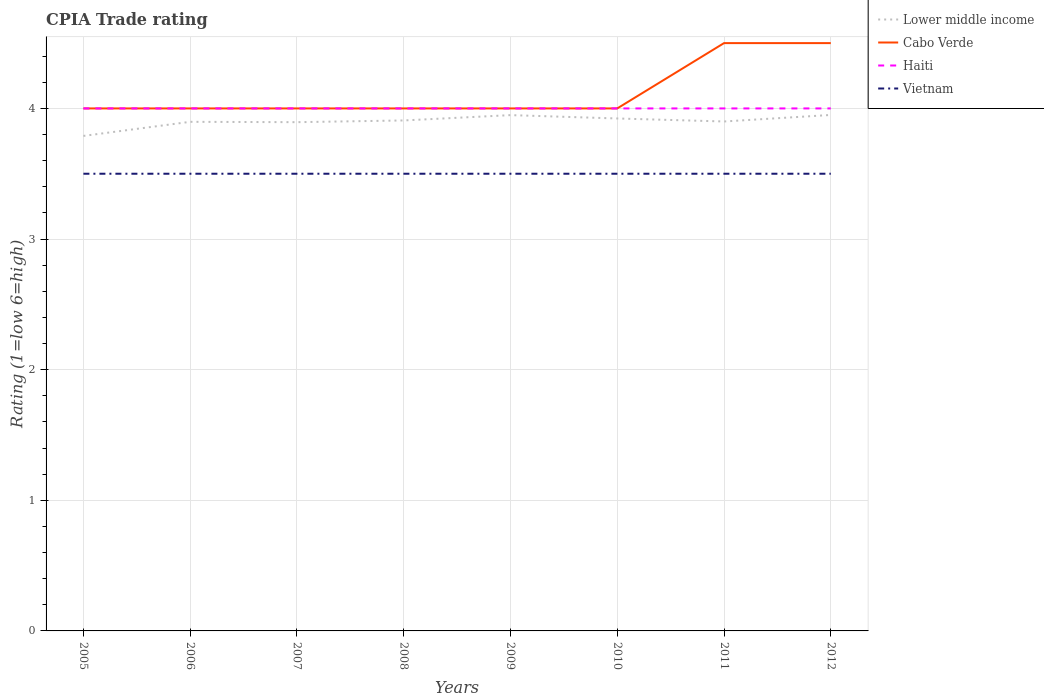Does the line corresponding to Lower middle income intersect with the line corresponding to Cabo Verde?
Your answer should be very brief. No. Is the number of lines equal to the number of legend labels?
Provide a short and direct response. Yes. In which year was the CPIA rating in Vietnam maximum?
Give a very brief answer. 2005. What is the total CPIA rating in Lower middle income in the graph?
Your answer should be compact. -0.12. What is the difference between the highest and the second highest CPIA rating in Lower middle income?
Offer a very short reply. 0.16. What is the difference between the highest and the lowest CPIA rating in Vietnam?
Ensure brevity in your answer.  0. How many lines are there?
Keep it short and to the point. 4. What is the difference between two consecutive major ticks on the Y-axis?
Your response must be concise. 1. Are the values on the major ticks of Y-axis written in scientific E-notation?
Offer a terse response. No. Does the graph contain any zero values?
Your answer should be very brief. No. How are the legend labels stacked?
Provide a succinct answer. Vertical. What is the title of the graph?
Offer a terse response. CPIA Trade rating. Does "European Union" appear as one of the legend labels in the graph?
Provide a succinct answer. No. What is the Rating (1=low 6=high) in Lower middle income in 2005?
Ensure brevity in your answer.  3.79. What is the Rating (1=low 6=high) in Cabo Verde in 2005?
Offer a very short reply. 4. What is the Rating (1=low 6=high) in Lower middle income in 2006?
Make the answer very short. 3.9. What is the Rating (1=low 6=high) in Cabo Verde in 2006?
Give a very brief answer. 4. What is the Rating (1=low 6=high) in Haiti in 2006?
Provide a short and direct response. 4. What is the Rating (1=low 6=high) of Lower middle income in 2007?
Your response must be concise. 3.89. What is the Rating (1=low 6=high) in Cabo Verde in 2007?
Offer a very short reply. 4. What is the Rating (1=low 6=high) of Lower middle income in 2008?
Ensure brevity in your answer.  3.91. What is the Rating (1=low 6=high) of Vietnam in 2008?
Give a very brief answer. 3.5. What is the Rating (1=low 6=high) in Lower middle income in 2009?
Your response must be concise. 3.95. What is the Rating (1=low 6=high) of Haiti in 2009?
Offer a terse response. 4. What is the Rating (1=low 6=high) in Lower middle income in 2010?
Your response must be concise. 3.92. What is the Rating (1=low 6=high) in Haiti in 2010?
Provide a succinct answer. 4. What is the Rating (1=low 6=high) of Vietnam in 2010?
Your answer should be compact. 3.5. What is the Rating (1=low 6=high) of Haiti in 2011?
Make the answer very short. 4. What is the Rating (1=low 6=high) of Vietnam in 2011?
Ensure brevity in your answer.  3.5. What is the Rating (1=low 6=high) in Lower middle income in 2012?
Make the answer very short. 3.95. What is the Rating (1=low 6=high) in Cabo Verde in 2012?
Provide a short and direct response. 4.5. What is the Rating (1=low 6=high) in Haiti in 2012?
Make the answer very short. 4. What is the Rating (1=low 6=high) of Vietnam in 2012?
Your answer should be very brief. 3.5. Across all years, what is the maximum Rating (1=low 6=high) in Lower middle income?
Offer a terse response. 3.95. Across all years, what is the maximum Rating (1=low 6=high) of Cabo Verde?
Your answer should be very brief. 4.5. Across all years, what is the maximum Rating (1=low 6=high) of Haiti?
Your response must be concise. 4. Across all years, what is the minimum Rating (1=low 6=high) in Lower middle income?
Your response must be concise. 3.79. Across all years, what is the minimum Rating (1=low 6=high) in Haiti?
Make the answer very short. 4. Across all years, what is the minimum Rating (1=low 6=high) of Vietnam?
Offer a terse response. 3.5. What is the total Rating (1=low 6=high) of Lower middle income in the graph?
Offer a terse response. 31.21. What is the total Rating (1=low 6=high) of Haiti in the graph?
Offer a very short reply. 32. What is the total Rating (1=low 6=high) in Vietnam in the graph?
Provide a short and direct response. 28. What is the difference between the Rating (1=low 6=high) of Lower middle income in 2005 and that in 2006?
Offer a terse response. -0.11. What is the difference between the Rating (1=low 6=high) in Haiti in 2005 and that in 2006?
Offer a very short reply. 0. What is the difference between the Rating (1=low 6=high) of Lower middle income in 2005 and that in 2007?
Your answer should be compact. -0.11. What is the difference between the Rating (1=low 6=high) of Lower middle income in 2005 and that in 2008?
Give a very brief answer. -0.12. What is the difference between the Rating (1=low 6=high) in Haiti in 2005 and that in 2008?
Your answer should be very brief. 0. What is the difference between the Rating (1=low 6=high) in Vietnam in 2005 and that in 2008?
Provide a short and direct response. 0. What is the difference between the Rating (1=low 6=high) in Lower middle income in 2005 and that in 2009?
Provide a succinct answer. -0.16. What is the difference between the Rating (1=low 6=high) of Vietnam in 2005 and that in 2009?
Your response must be concise. 0. What is the difference between the Rating (1=low 6=high) in Lower middle income in 2005 and that in 2010?
Offer a terse response. -0.13. What is the difference between the Rating (1=low 6=high) of Haiti in 2005 and that in 2010?
Offer a very short reply. 0. What is the difference between the Rating (1=low 6=high) of Lower middle income in 2005 and that in 2011?
Keep it short and to the point. -0.11. What is the difference between the Rating (1=low 6=high) of Cabo Verde in 2005 and that in 2011?
Make the answer very short. -0.5. What is the difference between the Rating (1=low 6=high) of Lower middle income in 2005 and that in 2012?
Give a very brief answer. -0.16. What is the difference between the Rating (1=low 6=high) in Vietnam in 2005 and that in 2012?
Provide a short and direct response. 0. What is the difference between the Rating (1=low 6=high) in Lower middle income in 2006 and that in 2007?
Your response must be concise. 0. What is the difference between the Rating (1=low 6=high) in Cabo Verde in 2006 and that in 2007?
Give a very brief answer. 0. What is the difference between the Rating (1=low 6=high) of Haiti in 2006 and that in 2007?
Give a very brief answer. 0. What is the difference between the Rating (1=low 6=high) in Vietnam in 2006 and that in 2007?
Make the answer very short. 0. What is the difference between the Rating (1=low 6=high) in Lower middle income in 2006 and that in 2008?
Your answer should be very brief. -0.01. What is the difference between the Rating (1=low 6=high) in Haiti in 2006 and that in 2008?
Make the answer very short. 0. What is the difference between the Rating (1=low 6=high) in Vietnam in 2006 and that in 2008?
Ensure brevity in your answer.  0. What is the difference between the Rating (1=low 6=high) of Lower middle income in 2006 and that in 2009?
Your answer should be compact. -0.05. What is the difference between the Rating (1=low 6=high) in Cabo Verde in 2006 and that in 2009?
Make the answer very short. 0. What is the difference between the Rating (1=low 6=high) of Lower middle income in 2006 and that in 2010?
Your answer should be compact. -0.03. What is the difference between the Rating (1=low 6=high) in Vietnam in 2006 and that in 2010?
Give a very brief answer. 0. What is the difference between the Rating (1=low 6=high) of Lower middle income in 2006 and that in 2011?
Your response must be concise. -0. What is the difference between the Rating (1=low 6=high) in Haiti in 2006 and that in 2011?
Make the answer very short. 0. What is the difference between the Rating (1=low 6=high) in Vietnam in 2006 and that in 2011?
Provide a succinct answer. 0. What is the difference between the Rating (1=low 6=high) of Lower middle income in 2006 and that in 2012?
Your response must be concise. -0.05. What is the difference between the Rating (1=low 6=high) of Cabo Verde in 2006 and that in 2012?
Provide a succinct answer. -0.5. What is the difference between the Rating (1=low 6=high) in Haiti in 2006 and that in 2012?
Offer a very short reply. 0. What is the difference between the Rating (1=low 6=high) in Lower middle income in 2007 and that in 2008?
Keep it short and to the point. -0.01. What is the difference between the Rating (1=low 6=high) of Haiti in 2007 and that in 2008?
Offer a terse response. 0. What is the difference between the Rating (1=low 6=high) of Vietnam in 2007 and that in 2008?
Your response must be concise. 0. What is the difference between the Rating (1=low 6=high) of Lower middle income in 2007 and that in 2009?
Ensure brevity in your answer.  -0.05. What is the difference between the Rating (1=low 6=high) in Cabo Verde in 2007 and that in 2009?
Offer a terse response. 0. What is the difference between the Rating (1=low 6=high) in Vietnam in 2007 and that in 2009?
Offer a terse response. 0. What is the difference between the Rating (1=low 6=high) in Lower middle income in 2007 and that in 2010?
Your answer should be compact. -0.03. What is the difference between the Rating (1=low 6=high) in Lower middle income in 2007 and that in 2011?
Provide a succinct answer. -0.01. What is the difference between the Rating (1=low 6=high) in Haiti in 2007 and that in 2011?
Ensure brevity in your answer.  0. What is the difference between the Rating (1=low 6=high) of Vietnam in 2007 and that in 2011?
Your answer should be very brief. 0. What is the difference between the Rating (1=low 6=high) in Lower middle income in 2007 and that in 2012?
Ensure brevity in your answer.  -0.06. What is the difference between the Rating (1=low 6=high) of Lower middle income in 2008 and that in 2009?
Your answer should be compact. -0.04. What is the difference between the Rating (1=low 6=high) of Cabo Verde in 2008 and that in 2009?
Provide a succinct answer. 0. What is the difference between the Rating (1=low 6=high) of Haiti in 2008 and that in 2009?
Ensure brevity in your answer.  0. What is the difference between the Rating (1=low 6=high) in Lower middle income in 2008 and that in 2010?
Offer a very short reply. -0.02. What is the difference between the Rating (1=low 6=high) in Cabo Verde in 2008 and that in 2010?
Ensure brevity in your answer.  0. What is the difference between the Rating (1=low 6=high) of Lower middle income in 2008 and that in 2011?
Provide a short and direct response. 0.01. What is the difference between the Rating (1=low 6=high) in Cabo Verde in 2008 and that in 2011?
Keep it short and to the point. -0.5. What is the difference between the Rating (1=low 6=high) in Haiti in 2008 and that in 2011?
Ensure brevity in your answer.  0. What is the difference between the Rating (1=low 6=high) in Vietnam in 2008 and that in 2011?
Your answer should be very brief. 0. What is the difference between the Rating (1=low 6=high) of Lower middle income in 2008 and that in 2012?
Your answer should be compact. -0.04. What is the difference between the Rating (1=low 6=high) in Cabo Verde in 2008 and that in 2012?
Your response must be concise. -0.5. What is the difference between the Rating (1=low 6=high) in Lower middle income in 2009 and that in 2010?
Provide a short and direct response. 0.03. What is the difference between the Rating (1=low 6=high) in Vietnam in 2009 and that in 2010?
Keep it short and to the point. 0. What is the difference between the Rating (1=low 6=high) of Lower middle income in 2009 and that in 2011?
Your answer should be compact. 0.05. What is the difference between the Rating (1=low 6=high) in Cabo Verde in 2009 and that in 2011?
Provide a short and direct response. -0.5. What is the difference between the Rating (1=low 6=high) in Vietnam in 2009 and that in 2011?
Provide a short and direct response. 0. What is the difference between the Rating (1=low 6=high) of Lower middle income in 2009 and that in 2012?
Your answer should be compact. -0. What is the difference between the Rating (1=low 6=high) in Cabo Verde in 2009 and that in 2012?
Keep it short and to the point. -0.5. What is the difference between the Rating (1=low 6=high) in Lower middle income in 2010 and that in 2011?
Keep it short and to the point. 0.02. What is the difference between the Rating (1=low 6=high) of Cabo Verde in 2010 and that in 2011?
Make the answer very short. -0.5. What is the difference between the Rating (1=low 6=high) in Haiti in 2010 and that in 2011?
Give a very brief answer. 0. What is the difference between the Rating (1=low 6=high) of Lower middle income in 2010 and that in 2012?
Your answer should be compact. -0.03. What is the difference between the Rating (1=low 6=high) in Cabo Verde in 2010 and that in 2012?
Provide a short and direct response. -0.5. What is the difference between the Rating (1=low 6=high) in Vietnam in 2010 and that in 2012?
Offer a terse response. 0. What is the difference between the Rating (1=low 6=high) in Lower middle income in 2011 and that in 2012?
Provide a succinct answer. -0.05. What is the difference between the Rating (1=low 6=high) in Haiti in 2011 and that in 2012?
Provide a short and direct response. 0. What is the difference between the Rating (1=low 6=high) in Vietnam in 2011 and that in 2012?
Your answer should be compact. 0. What is the difference between the Rating (1=low 6=high) in Lower middle income in 2005 and the Rating (1=low 6=high) in Cabo Verde in 2006?
Provide a short and direct response. -0.21. What is the difference between the Rating (1=low 6=high) in Lower middle income in 2005 and the Rating (1=low 6=high) in Haiti in 2006?
Provide a succinct answer. -0.21. What is the difference between the Rating (1=low 6=high) in Lower middle income in 2005 and the Rating (1=low 6=high) in Vietnam in 2006?
Ensure brevity in your answer.  0.29. What is the difference between the Rating (1=low 6=high) in Cabo Verde in 2005 and the Rating (1=low 6=high) in Vietnam in 2006?
Ensure brevity in your answer.  0.5. What is the difference between the Rating (1=low 6=high) in Haiti in 2005 and the Rating (1=low 6=high) in Vietnam in 2006?
Your answer should be compact. 0.5. What is the difference between the Rating (1=low 6=high) in Lower middle income in 2005 and the Rating (1=low 6=high) in Cabo Verde in 2007?
Provide a succinct answer. -0.21. What is the difference between the Rating (1=low 6=high) in Lower middle income in 2005 and the Rating (1=low 6=high) in Haiti in 2007?
Make the answer very short. -0.21. What is the difference between the Rating (1=low 6=high) of Lower middle income in 2005 and the Rating (1=low 6=high) of Vietnam in 2007?
Ensure brevity in your answer.  0.29. What is the difference between the Rating (1=low 6=high) of Lower middle income in 2005 and the Rating (1=low 6=high) of Cabo Verde in 2008?
Provide a succinct answer. -0.21. What is the difference between the Rating (1=low 6=high) of Lower middle income in 2005 and the Rating (1=low 6=high) of Haiti in 2008?
Make the answer very short. -0.21. What is the difference between the Rating (1=low 6=high) of Lower middle income in 2005 and the Rating (1=low 6=high) of Vietnam in 2008?
Offer a very short reply. 0.29. What is the difference between the Rating (1=low 6=high) of Cabo Verde in 2005 and the Rating (1=low 6=high) of Haiti in 2008?
Your answer should be very brief. 0. What is the difference between the Rating (1=low 6=high) in Cabo Verde in 2005 and the Rating (1=low 6=high) in Vietnam in 2008?
Make the answer very short. 0.5. What is the difference between the Rating (1=low 6=high) of Lower middle income in 2005 and the Rating (1=low 6=high) of Cabo Verde in 2009?
Ensure brevity in your answer.  -0.21. What is the difference between the Rating (1=low 6=high) in Lower middle income in 2005 and the Rating (1=low 6=high) in Haiti in 2009?
Your answer should be compact. -0.21. What is the difference between the Rating (1=low 6=high) of Lower middle income in 2005 and the Rating (1=low 6=high) of Vietnam in 2009?
Ensure brevity in your answer.  0.29. What is the difference between the Rating (1=low 6=high) of Lower middle income in 2005 and the Rating (1=low 6=high) of Cabo Verde in 2010?
Provide a succinct answer. -0.21. What is the difference between the Rating (1=low 6=high) in Lower middle income in 2005 and the Rating (1=low 6=high) in Haiti in 2010?
Provide a short and direct response. -0.21. What is the difference between the Rating (1=low 6=high) of Lower middle income in 2005 and the Rating (1=low 6=high) of Vietnam in 2010?
Your answer should be very brief. 0.29. What is the difference between the Rating (1=low 6=high) in Cabo Verde in 2005 and the Rating (1=low 6=high) in Vietnam in 2010?
Your answer should be very brief. 0.5. What is the difference between the Rating (1=low 6=high) of Haiti in 2005 and the Rating (1=low 6=high) of Vietnam in 2010?
Offer a very short reply. 0.5. What is the difference between the Rating (1=low 6=high) of Lower middle income in 2005 and the Rating (1=low 6=high) of Cabo Verde in 2011?
Offer a terse response. -0.71. What is the difference between the Rating (1=low 6=high) of Lower middle income in 2005 and the Rating (1=low 6=high) of Haiti in 2011?
Offer a terse response. -0.21. What is the difference between the Rating (1=low 6=high) in Lower middle income in 2005 and the Rating (1=low 6=high) in Vietnam in 2011?
Make the answer very short. 0.29. What is the difference between the Rating (1=low 6=high) of Cabo Verde in 2005 and the Rating (1=low 6=high) of Vietnam in 2011?
Your answer should be compact. 0.5. What is the difference between the Rating (1=low 6=high) in Haiti in 2005 and the Rating (1=low 6=high) in Vietnam in 2011?
Provide a succinct answer. 0.5. What is the difference between the Rating (1=low 6=high) in Lower middle income in 2005 and the Rating (1=low 6=high) in Cabo Verde in 2012?
Your answer should be very brief. -0.71. What is the difference between the Rating (1=low 6=high) of Lower middle income in 2005 and the Rating (1=low 6=high) of Haiti in 2012?
Offer a very short reply. -0.21. What is the difference between the Rating (1=low 6=high) of Lower middle income in 2005 and the Rating (1=low 6=high) of Vietnam in 2012?
Provide a succinct answer. 0.29. What is the difference between the Rating (1=low 6=high) of Cabo Verde in 2005 and the Rating (1=low 6=high) of Haiti in 2012?
Your answer should be compact. 0. What is the difference between the Rating (1=low 6=high) in Cabo Verde in 2005 and the Rating (1=low 6=high) in Vietnam in 2012?
Your answer should be compact. 0.5. What is the difference between the Rating (1=low 6=high) of Lower middle income in 2006 and the Rating (1=low 6=high) of Cabo Verde in 2007?
Your answer should be very brief. -0.1. What is the difference between the Rating (1=low 6=high) of Lower middle income in 2006 and the Rating (1=low 6=high) of Haiti in 2007?
Provide a short and direct response. -0.1. What is the difference between the Rating (1=low 6=high) in Lower middle income in 2006 and the Rating (1=low 6=high) in Vietnam in 2007?
Your answer should be compact. 0.4. What is the difference between the Rating (1=low 6=high) in Cabo Verde in 2006 and the Rating (1=low 6=high) in Haiti in 2007?
Offer a very short reply. 0. What is the difference between the Rating (1=low 6=high) in Cabo Verde in 2006 and the Rating (1=low 6=high) in Vietnam in 2007?
Your answer should be very brief. 0.5. What is the difference between the Rating (1=low 6=high) in Haiti in 2006 and the Rating (1=low 6=high) in Vietnam in 2007?
Give a very brief answer. 0.5. What is the difference between the Rating (1=low 6=high) in Lower middle income in 2006 and the Rating (1=low 6=high) in Cabo Verde in 2008?
Offer a very short reply. -0.1. What is the difference between the Rating (1=low 6=high) of Lower middle income in 2006 and the Rating (1=low 6=high) of Haiti in 2008?
Offer a terse response. -0.1. What is the difference between the Rating (1=low 6=high) of Lower middle income in 2006 and the Rating (1=low 6=high) of Vietnam in 2008?
Provide a succinct answer. 0.4. What is the difference between the Rating (1=low 6=high) of Cabo Verde in 2006 and the Rating (1=low 6=high) of Vietnam in 2008?
Provide a short and direct response. 0.5. What is the difference between the Rating (1=low 6=high) in Haiti in 2006 and the Rating (1=low 6=high) in Vietnam in 2008?
Provide a succinct answer. 0.5. What is the difference between the Rating (1=low 6=high) of Lower middle income in 2006 and the Rating (1=low 6=high) of Cabo Verde in 2009?
Give a very brief answer. -0.1. What is the difference between the Rating (1=low 6=high) of Lower middle income in 2006 and the Rating (1=low 6=high) of Haiti in 2009?
Give a very brief answer. -0.1. What is the difference between the Rating (1=low 6=high) of Lower middle income in 2006 and the Rating (1=low 6=high) of Vietnam in 2009?
Ensure brevity in your answer.  0.4. What is the difference between the Rating (1=low 6=high) of Cabo Verde in 2006 and the Rating (1=low 6=high) of Haiti in 2009?
Make the answer very short. 0. What is the difference between the Rating (1=low 6=high) of Cabo Verde in 2006 and the Rating (1=low 6=high) of Vietnam in 2009?
Ensure brevity in your answer.  0.5. What is the difference between the Rating (1=low 6=high) in Haiti in 2006 and the Rating (1=low 6=high) in Vietnam in 2009?
Your answer should be very brief. 0.5. What is the difference between the Rating (1=low 6=high) of Lower middle income in 2006 and the Rating (1=low 6=high) of Cabo Verde in 2010?
Provide a short and direct response. -0.1. What is the difference between the Rating (1=low 6=high) of Lower middle income in 2006 and the Rating (1=low 6=high) of Haiti in 2010?
Provide a succinct answer. -0.1. What is the difference between the Rating (1=low 6=high) in Lower middle income in 2006 and the Rating (1=low 6=high) in Vietnam in 2010?
Provide a succinct answer. 0.4. What is the difference between the Rating (1=low 6=high) of Lower middle income in 2006 and the Rating (1=low 6=high) of Cabo Verde in 2011?
Offer a terse response. -0.6. What is the difference between the Rating (1=low 6=high) of Lower middle income in 2006 and the Rating (1=low 6=high) of Haiti in 2011?
Keep it short and to the point. -0.1. What is the difference between the Rating (1=low 6=high) in Lower middle income in 2006 and the Rating (1=low 6=high) in Vietnam in 2011?
Provide a succinct answer. 0.4. What is the difference between the Rating (1=low 6=high) in Cabo Verde in 2006 and the Rating (1=low 6=high) in Haiti in 2011?
Provide a succinct answer. 0. What is the difference between the Rating (1=low 6=high) of Haiti in 2006 and the Rating (1=low 6=high) of Vietnam in 2011?
Offer a terse response. 0.5. What is the difference between the Rating (1=low 6=high) in Lower middle income in 2006 and the Rating (1=low 6=high) in Cabo Verde in 2012?
Offer a very short reply. -0.6. What is the difference between the Rating (1=low 6=high) in Lower middle income in 2006 and the Rating (1=low 6=high) in Haiti in 2012?
Offer a terse response. -0.1. What is the difference between the Rating (1=low 6=high) in Lower middle income in 2006 and the Rating (1=low 6=high) in Vietnam in 2012?
Provide a succinct answer. 0.4. What is the difference between the Rating (1=low 6=high) of Cabo Verde in 2006 and the Rating (1=low 6=high) of Vietnam in 2012?
Provide a succinct answer. 0.5. What is the difference between the Rating (1=low 6=high) in Haiti in 2006 and the Rating (1=low 6=high) in Vietnam in 2012?
Offer a very short reply. 0.5. What is the difference between the Rating (1=low 6=high) of Lower middle income in 2007 and the Rating (1=low 6=high) of Cabo Verde in 2008?
Make the answer very short. -0.11. What is the difference between the Rating (1=low 6=high) of Lower middle income in 2007 and the Rating (1=low 6=high) of Haiti in 2008?
Your response must be concise. -0.11. What is the difference between the Rating (1=low 6=high) of Lower middle income in 2007 and the Rating (1=low 6=high) of Vietnam in 2008?
Ensure brevity in your answer.  0.39. What is the difference between the Rating (1=low 6=high) in Haiti in 2007 and the Rating (1=low 6=high) in Vietnam in 2008?
Your answer should be compact. 0.5. What is the difference between the Rating (1=low 6=high) of Lower middle income in 2007 and the Rating (1=low 6=high) of Cabo Verde in 2009?
Keep it short and to the point. -0.11. What is the difference between the Rating (1=low 6=high) of Lower middle income in 2007 and the Rating (1=low 6=high) of Haiti in 2009?
Make the answer very short. -0.11. What is the difference between the Rating (1=low 6=high) of Lower middle income in 2007 and the Rating (1=low 6=high) of Vietnam in 2009?
Keep it short and to the point. 0.39. What is the difference between the Rating (1=low 6=high) of Haiti in 2007 and the Rating (1=low 6=high) of Vietnam in 2009?
Make the answer very short. 0.5. What is the difference between the Rating (1=low 6=high) of Lower middle income in 2007 and the Rating (1=low 6=high) of Cabo Verde in 2010?
Provide a short and direct response. -0.11. What is the difference between the Rating (1=low 6=high) in Lower middle income in 2007 and the Rating (1=low 6=high) in Haiti in 2010?
Offer a very short reply. -0.11. What is the difference between the Rating (1=low 6=high) of Lower middle income in 2007 and the Rating (1=low 6=high) of Vietnam in 2010?
Provide a short and direct response. 0.39. What is the difference between the Rating (1=low 6=high) in Cabo Verde in 2007 and the Rating (1=low 6=high) in Haiti in 2010?
Provide a succinct answer. 0. What is the difference between the Rating (1=low 6=high) in Cabo Verde in 2007 and the Rating (1=low 6=high) in Vietnam in 2010?
Your answer should be compact. 0.5. What is the difference between the Rating (1=low 6=high) of Haiti in 2007 and the Rating (1=low 6=high) of Vietnam in 2010?
Ensure brevity in your answer.  0.5. What is the difference between the Rating (1=low 6=high) in Lower middle income in 2007 and the Rating (1=low 6=high) in Cabo Verde in 2011?
Provide a short and direct response. -0.61. What is the difference between the Rating (1=low 6=high) of Lower middle income in 2007 and the Rating (1=low 6=high) of Haiti in 2011?
Provide a succinct answer. -0.11. What is the difference between the Rating (1=low 6=high) of Lower middle income in 2007 and the Rating (1=low 6=high) of Vietnam in 2011?
Your answer should be very brief. 0.39. What is the difference between the Rating (1=low 6=high) of Cabo Verde in 2007 and the Rating (1=low 6=high) of Haiti in 2011?
Your response must be concise. 0. What is the difference between the Rating (1=low 6=high) of Lower middle income in 2007 and the Rating (1=low 6=high) of Cabo Verde in 2012?
Provide a short and direct response. -0.61. What is the difference between the Rating (1=low 6=high) of Lower middle income in 2007 and the Rating (1=low 6=high) of Haiti in 2012?
Make the answer very short. -0.11. What is the difference between the Rating (1=low 6=high) in Lower middle income in 2007 and the Rating (1=low 6=high) in Vietnam in 2012?
Offer a very short reply. 0.39. What is the difference between the Rating (1=low 6=high) in Cabo Verde in 2007 and the Rating (1=low 6=high) in Vietnam in 2012?
Offer a very short reply. 0.5. What is the difference between the Rating (1=low 6=high) of Haiti in 2007 and the Rating (1=low 6=high) of Vietnam in 2012?
Offer a terse response. 0.5. What is the difference between the Rating (1=low 6=high) in Lower middle income in 2008 and the Rating (1=low 6=high) in Cabo Verde in 2009?
Ensure brevity in your answer.  -0.09. What is the difference between the Rating (1=low 6=high) in Lower middle income in 2008 and the Rating (1=low 6=high) in Haiti in 2009?
Your answer should be very brief. -0.09. What is the difference between the Rating (1=low 6=high) in Lower middle income in 2008 and the Rating (1=low 6=high) in Vietnam in 2009?
Ensure brevity in your answer.  0.41. What is the difference between the Rating (1=low 6=high) of Cabo Verde in 2008 and the Rating (1=low 6=high) of Haiti in 2009?
Make the answer very short. 0. What is the difference between the Rating (1=low 6=high) of Lower middle income in 2008 and the Rating (1=low 6=high) of Cabo Verde in 2010?
Provide a succinct answer. -0.09. What is the difference between the Rating (1=low 6=high) in Lower middle income in 2008 and the Rating (1=low 6=high) in Haiti in 2010?
Keep it short and to the point. -0.09. What is the difference between the Rating (1=low 6=high) in Lower middle income in 2008 and the Rating (1=low 6=high) in Vietnam in 2010?
Offer a terse response. 0.41. What is the difference between the Rating (1=low 6=high) of Cabo Verde in 2008 and the Rating (1=low 6=high) of Vietnam in 2010?
Your response must be concise. 0.5. What is the difference between the Rating (1=low 6=high) of Lower middle income in 2008 and the Rating (1=low 6=high) of Cabo Verde in 2011?
Offer a terse response. -0.59. What is the difference between the Rating (1=low 6=high) in Lower middle income in 2008 and the Rating (1=low 6=high) in Haiti in 2011?
Your answer should be very brief. -0.09. What is the difference between the Rating (1=low 6=high) of Lower middle income in 2008 and the Rating (1=low 6=high) of Vietnam in 2011?
Keep it short and to the point. 0.41. What is the difference between the Rating (1=low 6=high) of Cabo Verde in 2008 and the Rating (1=low 6=high) of Haiti in 2011?
Give a very brief answer. 0. What is the difference between the Rating (1=low 6=high) of Cabo Verde in 2008 and the Rating (1=low 6=high) of Vietnam in 2011?
Ensure brevity in your answer.  0.5. What is the difference between the Rating (1=low 6=high) of Lower middle income in 2008 and the Rating (1=low 6=high) of Cabo Verde in 2012?
Your answer should be very brief. -0.59. What is the difference between the Rating (1=low 6=high) in Lower middle income in 2008 and the Rating (1=low 6=high) in Haiti in 2012?
Your answer should be compact. -0.09. What is the difference between the Rating (1=low 6=high) of Lower middle income in 2008 and the Rating (1=low 6=high) of Vietnam in 2012?
Give a very brief answer. 0.41. What is the difference between the Rating (1=low 6=high) in Cabo Verde in 2008 and the Rating (1=low 6=high) in Haiti in 2012?
Your response must be concise. 0. What is the difference between the Rating (1=low 6=high) in Lower middle income in 2009 and the Rating (1=low 6=high) in Cabo Verde in 2010?
Provide a succinct answer. -0.05. What is the difference between the Rating (1=low 6=high) in Lower middle income in 2009 and the Rating (1=low 6=high) in Haiti in 2010?
Keep it short and to the point. -0.05. What is the difference between the Rating (1=low 6=high) in Lower middle income in 2009 and the Rating (1=low 6=high) in Vietnam in 2010?
Ensure brevity in your answer.  0.45. What is the difference between the Rating (1=low 6=high) of Lower middle income in 2009 and the Rating (1=low 6=high) of Cabo Verde in 2011?
Provide a short and direct response. -0.55. What is the difference between the Rating (1=low 6=high) of Lower middle income in 2009 and the Rating (1=low 6=high) of Haiti in 2011?
Give a very brief answer. -0.05. What is the difference between the Rating (1=low 6=high) of Lower middle income in 2009 and the Rating (1=low 6=high) of Vietnam in 2011?
Your answer should be very brief. 0.45. What is the difference between the Rating (1=low 6=high) in Cabo Verde in 2009 and the Rating (1=low 6=high) in Vietnam in 2011?
Ensure brevity in your answer.  0.5. What is the difference between the Rating (1=low 6=high) of Haiti in 2009 and the Rating (1=low 6=high) of Vietnam in 2011?
Your answer should be compact. 0.5. What is the difference between the Rating (1=low 6=high) in Lower middle income in 2009 and the Rating (1=low 6=high) in Cabo Verde in 2012?
Ensure brevity in your answer.  -0.55. What is the difference between the Rating (1=low 6=high) of Lower middle income in 2009 and the Rating (1=low 6=high) of Haiti in 2012?
Make the answer very short. -0.05. What is the difference between the Rating (1=low 6=high) of Lower middle income in 2009 and the Rating (1=low 6=high) of Vietnam in 2012?
Offer a very short reply. 0.45. What is the difference between the Rating (1=low 6=high) of Cabo Verde in 2009 and the Rating (1=low 6=high) of Haiti in 2012?
Ensure brevity in your answer.  0. What is the difference between the Rating (1=low 6=high) of Cabo Verde in 2009 and the Rating (1=low 6=high) of Vietnam in 2012?
Give a very brief answer. 0.5. What is the difference between the Rating (1=low 6=high) of Lower middle income in 2010 and the Rating (1=low 6=high) of Cabo Verde in 2011?
Give a very brief answer. -0.58. What is the difference between the Rating (1=low 6=high) in Lower middle income in 2010 and the Rating (1=low 6=high) in Haiti in 2011?
Your answer should be very brief. -0.08. What is the difference between the Rating (1=low 6=high) of Lower middle income in 2010 and the Rating (1=low 6=high) of Vietnam in 2011?
Ensure brevity in your answer.  0.42. What is the difference between the Rating (1=low 6=high) in Cabo Verde in 2010 and the Rating (1=low 6=high) in Vietnam in 2011?
Your response must be concise. 0.5. What is the difference between the Rating (1=low 6=high) of Lower middle income in 2010 and the Rating (1=low 6=high) of Cabo Verde in 2012?
Ensure brevity in your answer.  -0.58. What is the difference between the Rating (1=low 6=high) of Lower middle income in 2010 and the Rating (1=low 6=high) of Haiti in 2012?
Your answer should be very brief. -0.08. What is the difference between the Rating (1=low 6=high) in Lower middle income in 2010 and the Rating (1=low 6=high) in Vietnam in 2012?
Your answer should be compact. 0.42. What is the difference between the Rating (1=low 6=high) in Cabo Verde in 2010 and the Rating (1=low 6=high) in Haiti in 2012?
Offer a very short reply. 0. What is the difference between the Rating (1=low 6=high) of Haiti in 2010 and the Rating (1=low 6=high) of Vietnam in 2012?
Your response must be concise. 0.5. What is the difference between the Rating (1=low 6=high) of Lower middle income in 2011 and the Rating (1=low 6=high) of Cabo Verde in 2012?
Provide a short and direct response. -0.6. What is the difference between the Rating (1=low 6=high) in Lower middle income in 2011 and the Rating (1=low 6=high) in Haiti in 2012?
Your answer should be very brief. -0.1. What is the difference between the Rating (1=low 6=high) of Cabo Verde in 2011 and the Rating (1=low 6=high) of Haiti in 2012?
Offer a very short reply. 0.5. What is the average Rating (1=low 6=high) of Lower middle income per year?
Offer a terse response. 3.9. What is the average Rating (1=low 6=high) of Cabo Verde per year?
Your answer should be compact. 4.12. What is the average Rating (1=low 6=high) of Vietnam per year?
Your response must be concise. 3.5. In the year 2005, what is the difference between the Rating (1=low 6=high) of Lower middle income and Rating (1=low 6=high) of Cabo Verde?
Offer a very short reply. -0.21. In the year 2005, what is the difference between the Rating (1=low 6=high) in Lower middle income and Rating (1=low 6=high) in Haiti?
Your answer should be compact. -0.21. In the year 2005, what is the difference between the Rating (1=low 6=high) of Lower middle income and Rating (1=low 6=high) of Vietnam?
Provide a short and direct response. 0.29. In the year 2005, what is the difference between the Rating (1=low 6=high) of Cabo Verde and Rating (1=low 6=high) of Haiti?
Ensure brevity in your answer.  0. In the year 2005, what is the difference between the Rating (1=low 6=high) of Haiti and Rating (1=low 6=high) of Vietnam?
Keep it short and to the point. 0.5. In the year 2006, what is the difference between the Rating (1=low 6=high) of Lower middle income and Rating (1=low 6=high) of Cabo Verde?
Provide a succinct answer. -0.1. In the year 2006, what is the difference between the Rating (1=low 6=high) in Lower middle income and Rating (1=low 6=high) in Haiti?
Keep it short and to the point. -0.1. In the year 2006, what is the difference between the Rating (1=low 6=high) in Lower middle income and Rating (1=low 6=high) in Vietnam?
Offer a terse response. 0.4. In the year 2006, what is the difference between the Rating (1=low 6=high) in Cabo Verde and Rating (1=low 6=high) in Haiti?
Ensure brevity in your answer.  0. In the year 2007, what is the difference between the Rating (1=low 6=high) of Lower middle income and Rating (1=low 6=high) of Cabo Verde?
Your response must be concise. -0.11. In the year 2007, what is the difference between the Rating (1=low 6=high) in Lower middle income and Rating (1=low 6=high) in Haiti?
Give a very brief answer. -0.11. In the year 2007, what is the difference between the Rating (1=low 6=high) in Lower middle income and Rating (1=low 6=high) in Vietnam?
Offer a very short reply. 0.39. In the year 2007, what is the difference between the Rating (1=low 6=high) of Haiti and Rating (1=low 6=high) of Vietnam?
Your answer should be very brief. 0.5. In the year 2008, what is the difference between the Rating (1=low 6=high) of Lower middle income and Rating (1=low 6=high) of Cabo Verde?
Make the answer very short. -0.09. In the year 2008, what is the difference between the Rating (1=low 6=high) in Lower middle income and Rating (1=low 6=high) in Haiti?
Make the answer very short. -0.09. In the year 2008, what is the difference between the Rating (1=low 6=high) in Lower middle income and Rating (1=low 6=high) in Vietnam?
Offer a very short reply. 0.41. In the year 2009, what is the difference between the Rating (1=low 6=high) in Lower middle income and Rating (1=low 6=high) in Cabo Verde?
Ensure brevity in your answer.  -0.05. In the year 2009, what is the difference between the Rating (1=low 6=high) in Lower middle income and Rating (1=low 6=high) in Haiti?
Offer a terse response. -0.05. In the year 2009, what is the difference between the Rating (1=low 6=high) of Lower middle income and Rating (1=low 6=high) of Vietnam?
Ensure brevity in your answer.  0.45. In the year 2009, what is the difference between the Rating (1=low 6=high) of Cabo Verde and Rating (1=low 6=high) of Haiti?
Offer a very short reply. 0. In the year 2009, what is the difference between the Rating (1=low 6=high) in Haiti and Rating (1=low 6=high) in Vietnam?
Ensure brevity in your answer.  0.5. In the year 2010, what is the difference between the Rating (1=low 6=high) in Lower middle income and Rating (1=low 6=high) in Cabo Verde?
Keep it short and to the point. -0.08. In the year 2010, what is the difference between the Rating (1=low 6=high) of Lower middle income and Rating (1=low 6=high) of Haiti?
Ensure brevity in your answer.  -0.08. In the year 2010, what is the difference between the Rating (1=low 6=high) in Lower middle income and Rating (1=low 6=high) in Vietnam?
Offer a terse response. 0.42. In the year 2010, what is the difference between the Rating (1=low 6=high) in Cabo Verde and Rating (1=low 6=high) in Haiti?
Give a very brief answer. 0. In the year 2011, what is the difference between the Rating (1=low 6=high) in Lower middle income and Rating (1=low 6=high) in Cabo Verde?
Offer a terse response. -0.6. In the year 2011, what is the difference between the Rating (1=low 6=high) of Lower middle income and Rating (1=low 6=high) of Vietnam?
Provide a short and direct response. 0.4. In the year 2011, what is the difference between the Rating (1=low 6=high) in Cabo Verde and Rating (1=low 6=high) in Haiti?
Your response must be concise. 0.5. In the year 2011, what is the difference between the Rating (1=low 6=high) of Cabo Verde and Rating (1=low 6=high) of Vietnam?
Your answer should be compact. 1. In the year 2011, what is the difference between the Rating (1=low 6=high) in Haiti and Rating (1=low 6=high) in Vietnam?
Give a very brief answer. 0.5. In the year 2012, what is the difference between the Rating (1=low 6=high) of Lower middle income and Rating (1=low 6=high) of Cabo Verde?
Provide a succinct answer. -0.55. In the year 2012, what is the difference between the Rating (1=low 6=high) in Lower middle income and Rating (1=low 6=high) in Haiti?
Ensure brevity in your answer.  -0.05. In the year 2012, what is the difference between the Rating (1=low 6=high) of Lower middle income and Rating (1=low 6=high) of Vietnam?
Your answer should be compact. 0.45. In the year 2012, what is the difference between the Rating (1=low 6=high) in Haiti and Rating (1=low 6=high) in Vietnam?
Make the answer very short. 0.5. What is the ratio of the Rating (1=low 6=high) of Lower middle income in 2005 to that in 2006?
Offer a terse response. 0.97. What is the ratio of the Rating (1=low 6=high) of Cabo Verde in 2005 to that in 2006?
Offer a very short reply. 1. What is the ratio of the Rating (1=low 6=high) of Cabo Verde in 2005 to that in 2007?
Ensure brevity in your answer.  1. What is the ratio of the Rating (1=low 6=high) in Lower middle income in 2005 to that in 2008?
Provide a succinct answer. 0.97. What is the ratio of the Rating (1=low 6=high) in Cabo Verde in 2005 to that in 2008?
Your answer should be very brief. 1. What is the ratio of the Rating (1=low 6=high) in Haiti in 2005 to that in 2008?
Offer a terse response. 1. What is the ratio of the Rating (1=low 6=high) of Lower middle income in 2005 to that in 2009?
Offer a very short reply. 0.96. What is the ratio of the Rating (1=low 6=high) in Haiti in 2005 to that in 2009?
Offer a very short reply. 1. What is the ratio of the Rating (1=low 6=high) in Vietnam in 2005 to that in 2009?
Give a very brief answer. 1. What is the ratio of the Rating (1=low 6=high) in Lower middle income in 2005 to that in 2010?
Make the answer very short. 0.97. What is the ratio of the Rating (1=low 6=high) in Cabo Verde in 2005 to that in 2010?
Your answer should be very brief. 1. What is the ratio of the Rating (1=low 6=high) in Haiti in 2005 to that in 2010?
Give a very brief answer. 1. What is the ratio of the Rating (1=low 6=high) of Lower middle income in 2005 to that in 2011?
Your response must be concise. 0.97. What is the ratio of the Rating (1=low 6=high) in Cabo Verde in 2005 to that in 2011?
Provide a short and direct response. 0.89. What is the ratio of the Rating (1=low 6=high) in Haiti in 2005 to that in 2011?
Keep it short and to the point. 1. What is the ratio of the Rating (1=low 6=high) in Lower middle income in 2005 to that in 2012?
Give a very brief answer. 0.96. What is the ratio of the Rating (1=low 6=high) in Cabo Verde in 2005 to that in 2012?
Provide a succinct answer. 0.89. What is the ratio of the Rating (1=low 6=high) in Lower middle income in 2006 to that in 2007?
Offer a very short reply. 1. What is the ratio of the Rating (1=low 6=high) in Haiti in 2006 to that in 2007?
Provide a succinct answer. 1. What is the ratio of the Rating (1=low 6=high) in Vietnam in 2006 to that in 2007?
Give a very brief answer. 1. What is the ratio of the Rating (1=low 6=high) of Lower middle income in 2006 to that in 2008?
Keep it short and to the point. 1. What is the ratio of the Rating (1=low 6=high) in Cabo Verde in 2006 to that in 2008?
Your answer should be very brief. 1. What is the ratio of the Rating (1=low 6=high) in Vietnam in 2006 to that in 2008?
Provide a short and direct response. 1. What is the ratio of the Rating (1=low 6=high) in Lower middle income in 2006 to that in 2009?
Offer a very short reply. 0.99. What is the ratio of the Rating (1=low 6=high) of Cabo Verde in 2006 to that in 2010?
Offer a terse response. 1. What is the ratio of the Rating (1=low 6=high) in Vietnam in 2006 to that in 2010?
Ensure brevity in your answer.  1. What is the ratio of the Rating (1=low 6=high) in Cabo Verde in 2006 to that in 2011?
Give a very brief answer. 0.89. What is the ratio of the Rating (1=low 6=high) in Vietnam in 2006 to that in 2011?
Give a very brief answer. 1. What is the ratio of the Rating (1=low 6=high) in Lower middle income in 2006 to that in 2012?
Make the answer very short. 0.99. What is the ratio of the Rating (1=low 6=high) in Vietnam in 2006 to that in 2012?
Your answer should be very brief. 1. What is the ratio of the Rating (1=low 6=high) of Cabo Verde in 2007 to that in 2008?
Provide a short and direct response. 1. What is the ratio of the Rating (1=low 6=high) in Vietnam in 2007 to that in 2008?
Offer a terse response. 1. What is the ratio of the Rating (1=low 6=high) in Lower middle income in 2007 to that in 2009?
Offer a terse response. 0.99. What is the ratio of the Rating (1=low 6=high) of Vietnam in 2007 to that in 2009?
Ensure brevity in your answer.  1. What is the ratio of the Rating (1=low 6=high) in Lower middle income in 2007 to that in 2010?
Your answer should be very brief. 0.99. What is the ratio of the Rating (1=low 6=high) in Vietnam in 2007 to that in 2010?
Keep it short and to the point. 1. What is the ratio of the Rating (1=low 6=high) in Haiti in 2007 to that in 2011?
Your answer should be very brief. 1. What is the ratio of the Rating (1=low 6=high) in Haiti in 2007 to that in 2012?
Your answer should be compact. 1. What is the ratio of the Rating (1=low 6=high) in Cabo Verde in 2008 to that in 2009?
Give a very brief answer. 1. What is the ratio of the Rating (1=low 6=high) of Lower middle income in 2008 to that in 2010?
Provide a short and direct response. 1. What is the ratio of the Rating (1=low 6=high) of Haiti in 2008 to that in 2011?
Provide a succinct answer. 1. What is the ratio of the Rating (1=low 6=high) in Lower middle income in 2008 to that in 2012?
Make the answer very short. 0.99. What is the ratio of the Rating (1=low 6=high) in Vietnam in 2008 to that in 2012?
Your answer should be very brief. 1. What is the ratio of the Rating (1=low 6=high) of Lower middle income in 2009 to that in 2010?
Offer a terse response. 1.01. What is the ratio of the Rating (1=low 6=high) of Haiti in 2009 to that in 2010?
Your answer should be very brief. 1. What is the ratio of the Rating (1=low 6=high) in Vietnam in 2009 to that in 2010?
Your answer should be very brief. 1. What is the ratio of the Rating (1=low 6=high) of Lower middle income in 2009 to that in 2011?
Give a very brief answer. 1.01. What is the ratio of the Rating (1=low 6=high) of Cabo Verde in 2009 to that in 2011?
Give a very brief answer. 0.89. What is the ratio of the Rating (1=low 6=high) in Vietnam in 2009 to that in 2011?
Offer a very short reply. 1. What is the ratio of the Rating (1=low 6=high) in Lower middle income in 2009 to that in 2012?
Your answer should be compact. 1. What is the ratio of the Rating (1=low 6=high) of Haiti in 2009 to that in 2012?
Your answer should be compact. 1. What is the ratio of the Rating (1=low 6=high) in Vietnam in 2009 to that in 2012?
Ensure brevity in your answer.  1. What is the ratio of the Rating (1=low 6=high) of Lower middle income in 2010 to that in 2011?
Keep it short and to the point. 1.01. What is the ratio of the Rating (1=low 6=high) in Cabo Verde in 2010 to that in 2011?
Your answer should be compact. 0.89. What is the ratio of the Rating (1=low 6=high) in Cabo Verde in 2010 to that in 2012?
Ensure brevity in your answer.  0.89. What is the ratio of the Rating (1=low 6=high) of Lower middle income in 2011 to that in 2012?
Ensure brevity in your answer.  0.99. What is the ratio of the Rating (1=low 6=high) in Cabo Verde in 2011 to that in 2012?
Your answer should be compact. 1. What is the ratio of the Rating (1=low 6=high) in Haiti in 2011 to that in 2012?
Make the answer very short. 1. What is the ratio of the Rating (1=low 6=high) of Vietnam in 2011 to that in 2012?
Provide a short and direct response. 1. What is the difference between the highest and the second highest Rating (1=low 6=high) in Lower middle income?
Your answer should be very brief. 0. What is the difference between the highest and the second highest Rating (1=low 6=high) in Cabo Verde?
Give a very brief answer. 0. What is the difference between the highest and the second highest Rating (1=low 6=high) of Haiti?
Offer a very short reply. 0. What is the difference between the highest and the second highest Rating (1=low 6=high) of Vietnam?
Ensure brevity in your answer.  0. What is the difference between the highest and the lowest Rating (1=low 6=high) in Lower middle income?
Ensure brevity in your answer.  0.16. What is the difference between the highest and the lowest Rating (1=low 6=high) of Cabo Verde?
Make the answer very short. 0.5. 